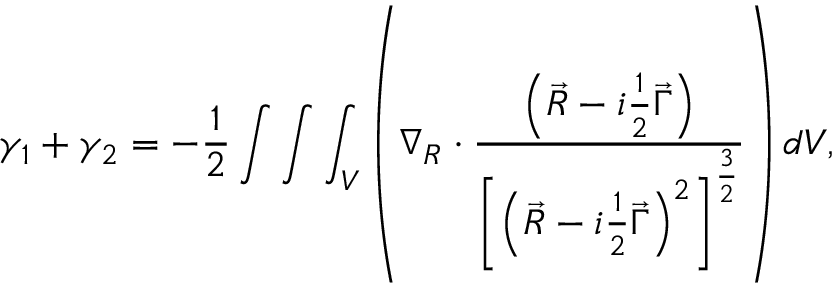Convert formula to latex. <formula><loc_0><loc_0><loc_500><loc_500>\gamma _ { 1 } + \gamma _ { 2 } = - \frac { 1 } { 2 } \int \int \int _ { V } \left ( \nabla _ { R } \cdot \frac { \left ( \vec { R } - i \frac { 1 } { 2 } \vec { \Gamma } \right ) } { \left [ \left ( \vec { R } - i \frac { 1 } { 2 } \vec { \Gamma } \right ) ^ { 2 } \right ] ^ { \frac { 3 } { 2 } } } \right ) d V ,</formula> 